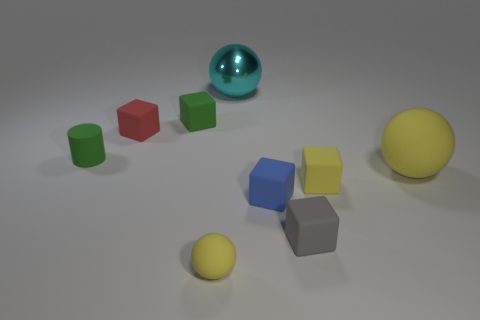There is a thing that is the same color as the small rubber cylinder; what size is it?
Give a very brief answer. Small. There is a tiny green object behind the small green rubber cylinder; is there a tiny matte object in front of it?
Provide a succinct answer. Yes. The block that is both in front of the tiny green rubber cube and left of the cyan thing is what color?
Offer a very short reply. Red. Are there any balls on the right side of the tiny yellow object that is on the right side of the large sphere left of the big yellow matte sphere?
Ensure brevity in your answer.  Yes. What size is the other matte thing that is the same shape as the big yellow thing?
Give a very brief answer. Small. Is there any other thing that has the same material as the cyan ball?
Offer a terse response. No. Are there any small red shiny things?
Make the answer very short. No. There is a tiny cylinder; is it the same color as the rubber object that is behind the red matte object?
Offer a very short reply. Yes. There is a yellow sphere that is in front of the yellow sphere behind the yellow ball to the left of the gray rubber thing; what is its size?
Your response must be concise. Small. What number of big matte objects have the same color as the tiny matte sphere?
Make the answer very short. 1. 